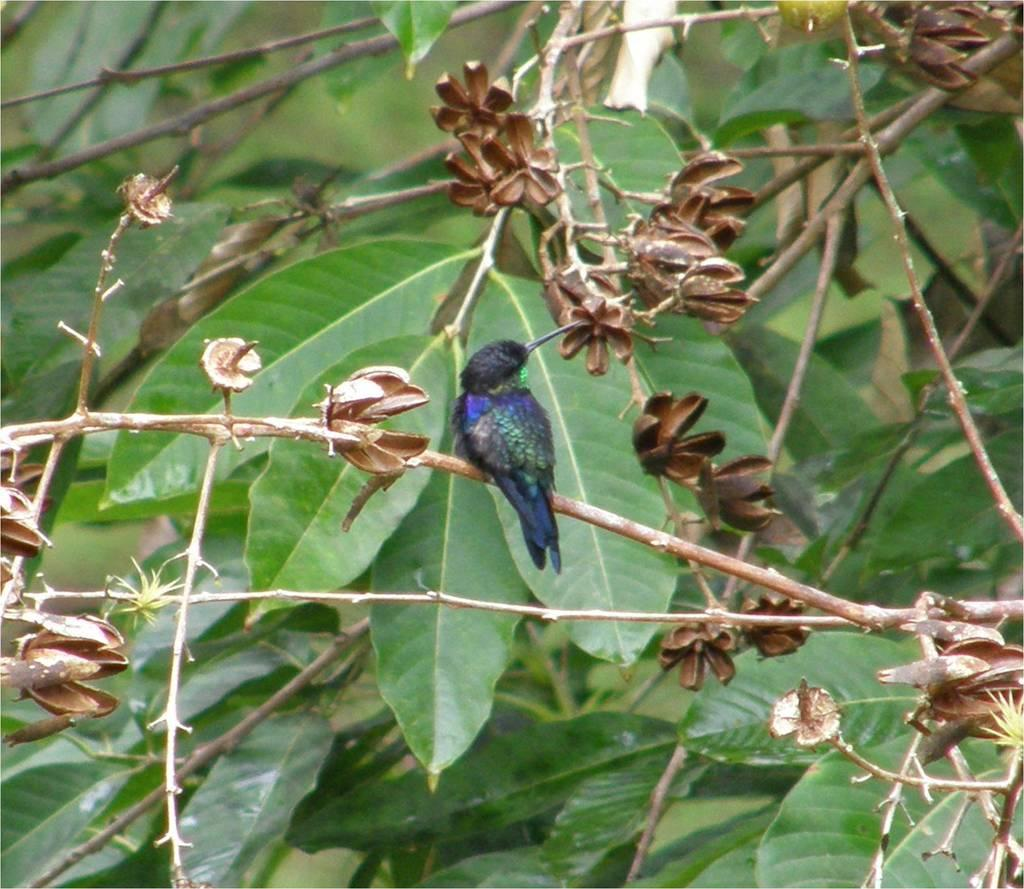Where was the image taken? The image was taken outdoors. What can be seen in the background of the image? There is a plant with green leaves in the background. What is present in the middle of the image? There is a bird on the stem in the middle of the image. What type of oatmeal is being served in the image? There is no oatmeal present in the image. What message of peace can be seen in the image? There is no message of peace depicted in the image; it features a bird on a stem. 